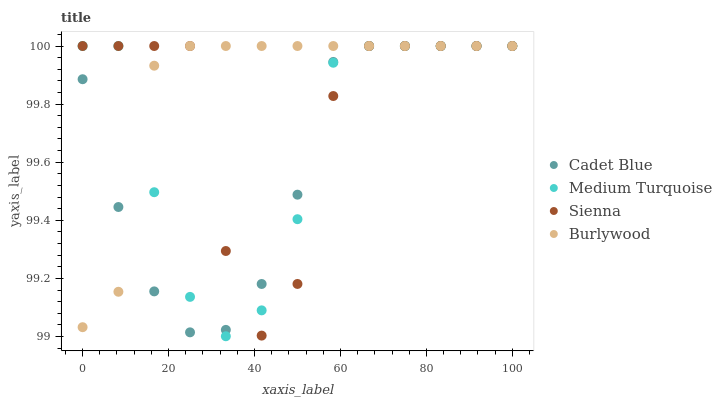Does Cadet Blue have the minimum area under the curve?
Answer yes or no. Yes. Does Burlywood have the maximum area under the curve?
Answer yes or no. Yes. Does Burlywood have the minimum area under the curve?
Answer yes or no. No. Does Cadet Blue have the maximum area under the curve?
Answer yes or no. No. Is Cadet Blue the smoothest?
Answer yes or no. Yes. Is Sienna the roughest?
Answer yes or no. Yes. Is Burlywood the smoothest?
Answer yes or no. No. Is Burlywood the roughest?
Answer yes or no. No. Does Medium Turquoise have the lowest value?
Answer yes or no. Yes. Does Cadet Blue have the lowest value?
Answer yes or no. No. Does Medium Turquoise have the highest value?
Answer yes or no. Yes. Does Burlywood intersect Medium Turquoise?
Answer yes or no. Yes. Is Burlywood less than Medium Turquoise?
Answer yes or no. No. Is Burlywood greater than Medium Turquoise?
Answer yes or no. No. 